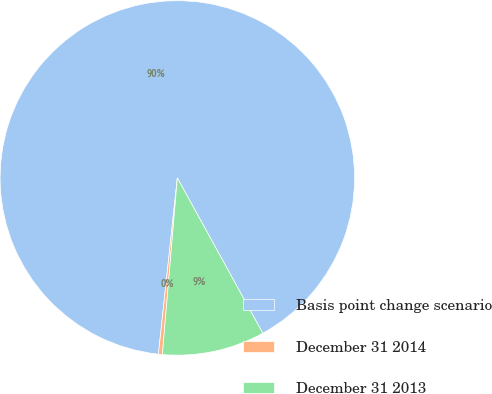Convert chart. <chart><loc_0><loc_0><loc_500><loc_500><pie_chart><fcel>Basis point change scenario<fcel>December 31 2014<fcel>December 31 2013<nl><fcel>90.29%<fcel>0.36%<fcel>9.35%<nl></chart> 